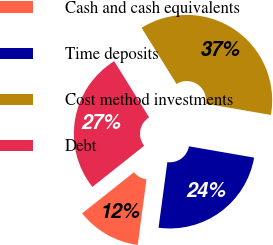Convert chart. <chart><loc_0><loc_0><loc_500><loc_500><pie_chart><fcel>Cash and cash equivalents<fcel>Time deposits<fcel>Cost method investments<fcel>Debt<nl><fcel>12.2%<fcel>24.39%<fcel>36.59%<fcel>26.83%<nl></chart> 